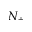<formula> <loc_0><loc_0><loc_500><loc_500>N _ { + }</formula> 